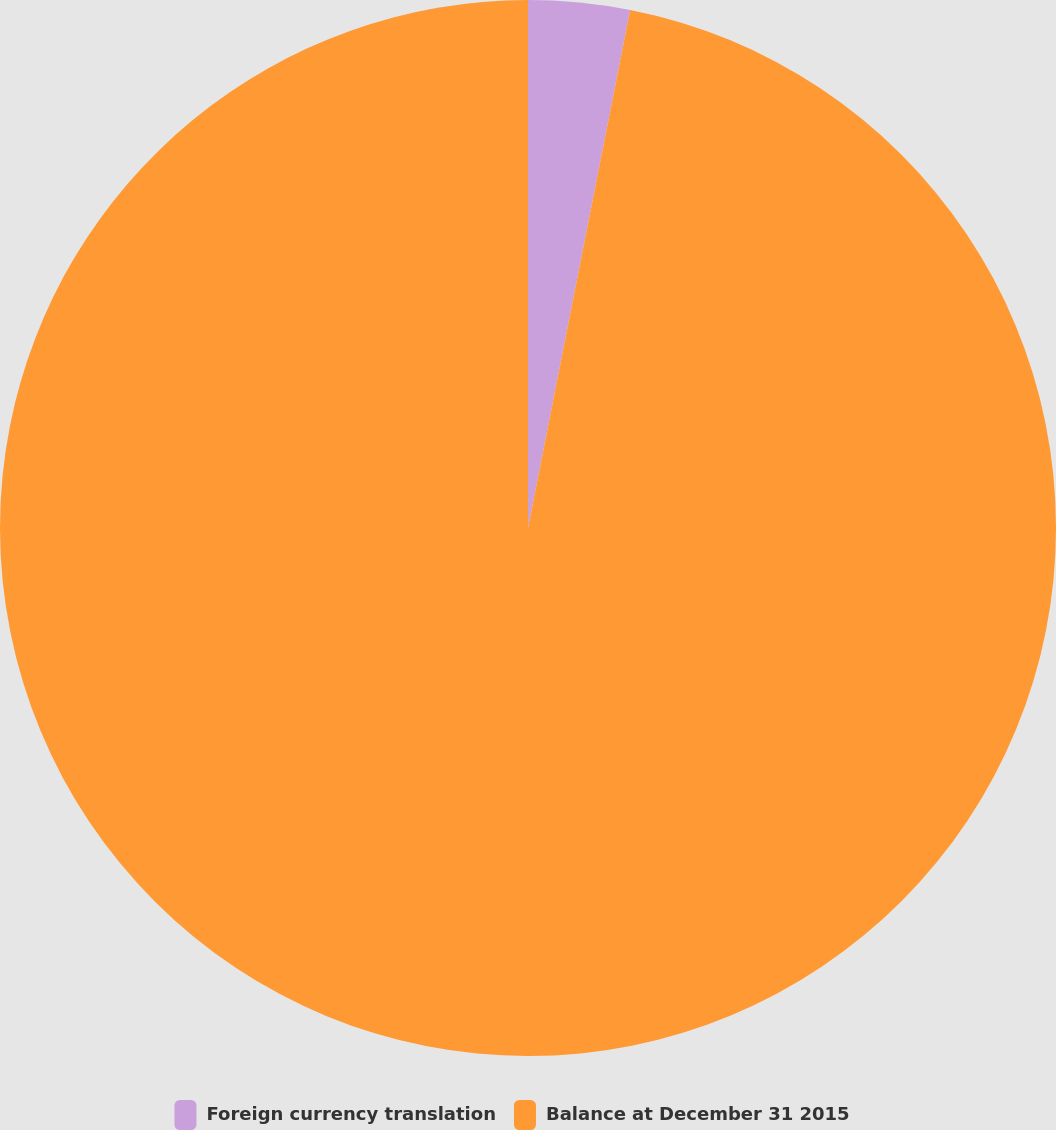Convert chart. <chart><loc_0><loc_0><loc_500><loc_500><pie_chart><fcel>Foreign currency translation<fcel>Balance at December 31 2015<nl><fcel>3.1%<fcel>96.9%<nl></chart> 